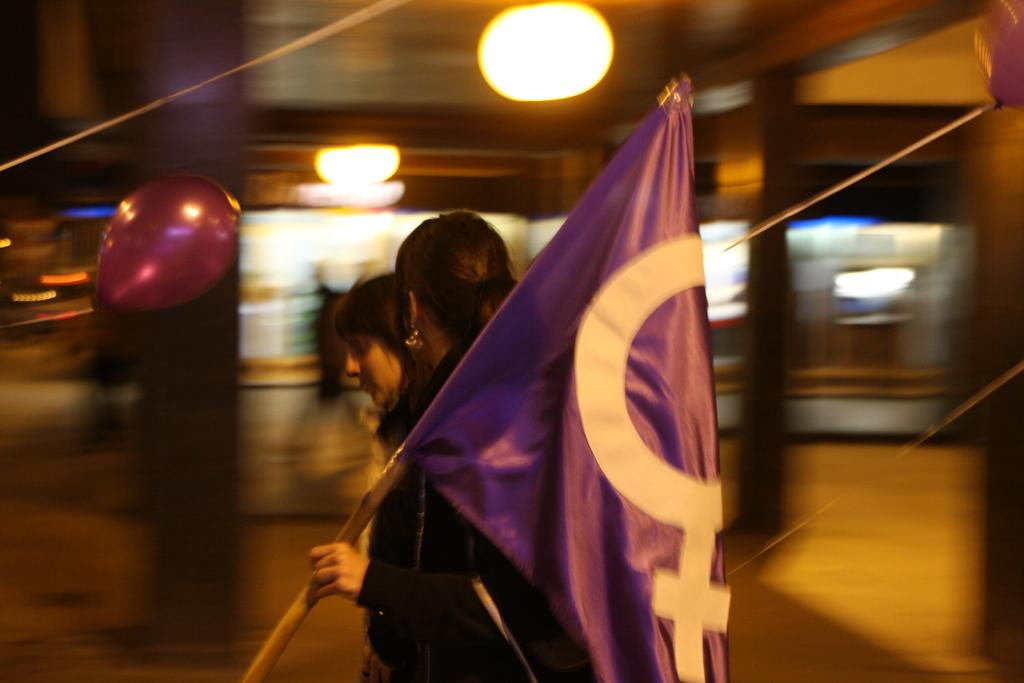How many people are in the image? There are two people standing in the center of the image. What are the people doing in the image? One person is holding a flag. What can be seen in the background of the image? There is a building, a balloon, and lights in the background of the image. How many pizzas are being stretched in the image? There are no pizzas present in the image, and therefore no stretching can be observed. 